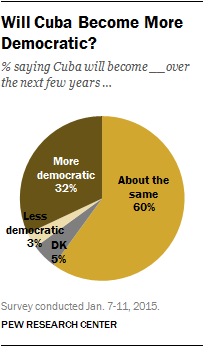Identify some key points in this picture. The ratio of the largest segment and the sum of the two smallest segments is 0.626388889... The color of the largest segment is yellow. 